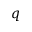<formula> <loc_0><loc_0><loc_500><loc_500>q</formula> 